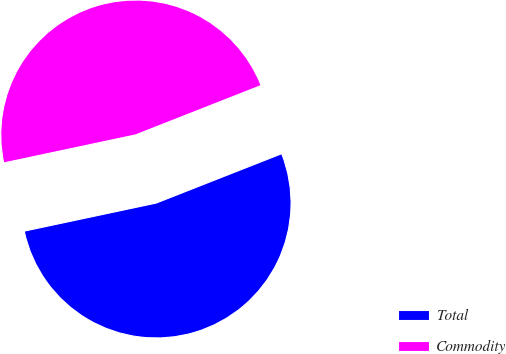<chart> <loc_0><loc_0><loc_500><loc_500><pie_chart><fcel>Total<fcel>Commodity<nl><fcel>52.63%<fcel>47.37%<nl></chart> 